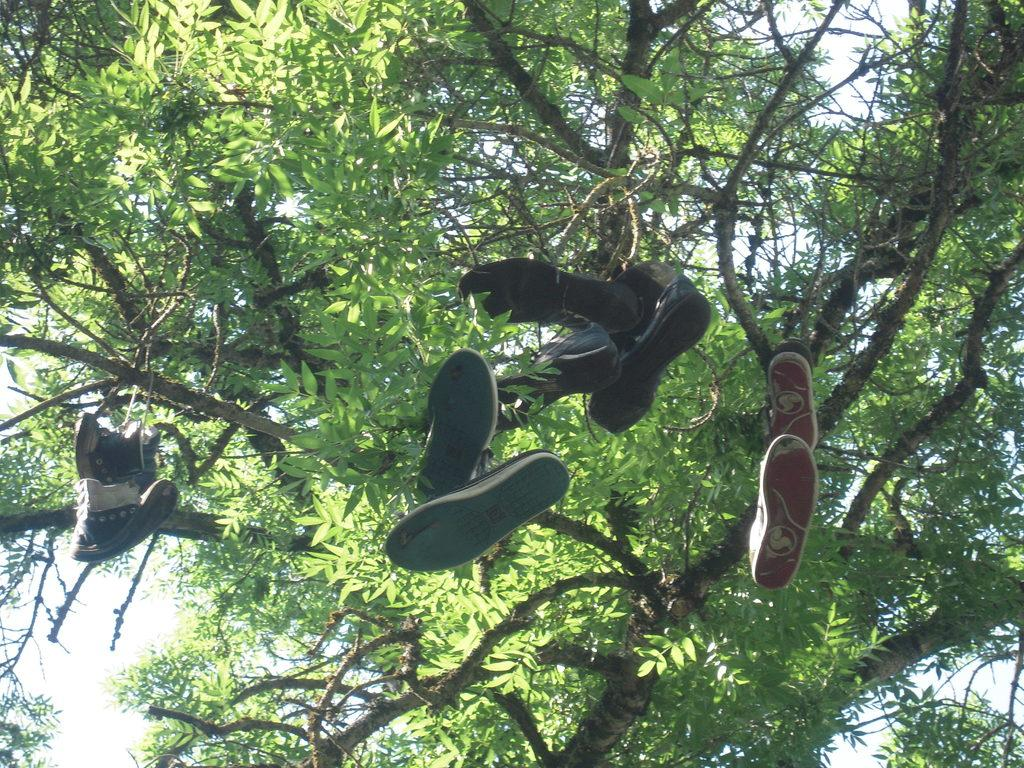What objects are in the image? There are shoes in the image. How are the shoes positioned in the image? The shoes are tied to a tree and hanging. What is in the background of the image? There is a tree in the background of the image. What type of tree is it? The tree appears to be a neem tree. What is your dad teaching in the image? There is no reference to a dad or any teaching activity in the image. 